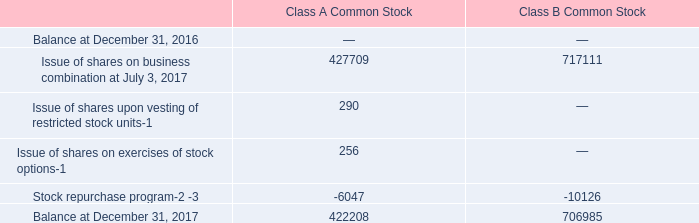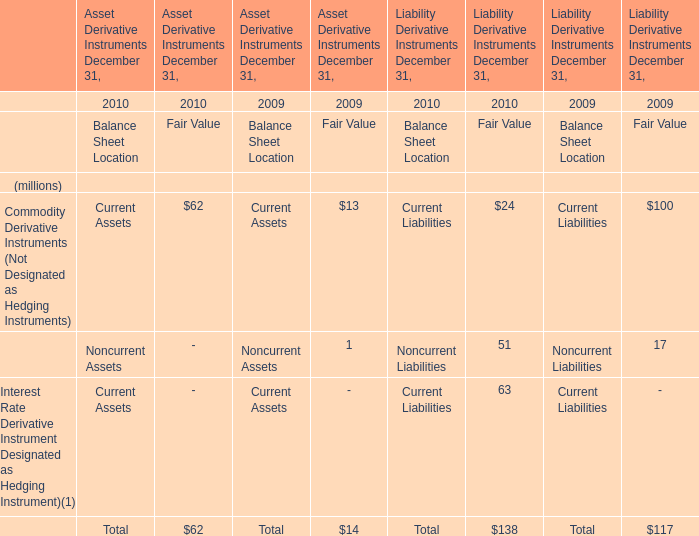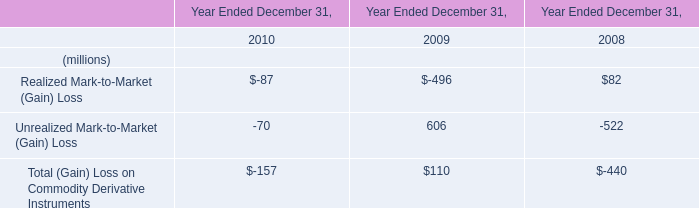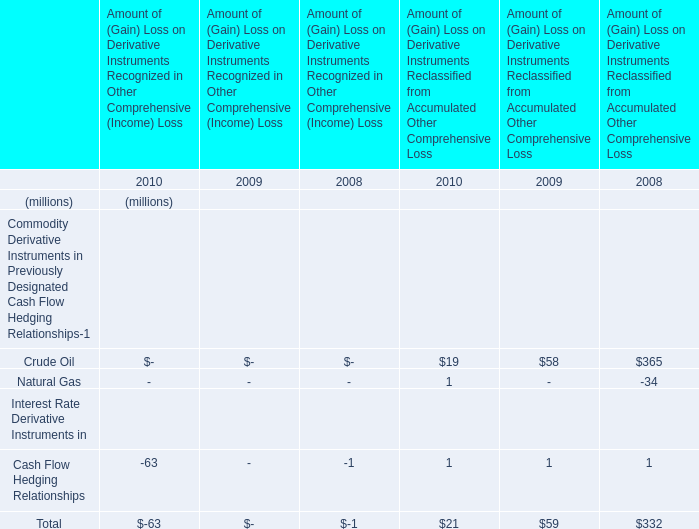What is the Unrealized Mark-to-Market (Gain) Loss in the year with the most Total (Gain) Loss on Commodity Derivative Instruments? (in million) 
Answer: 606. 